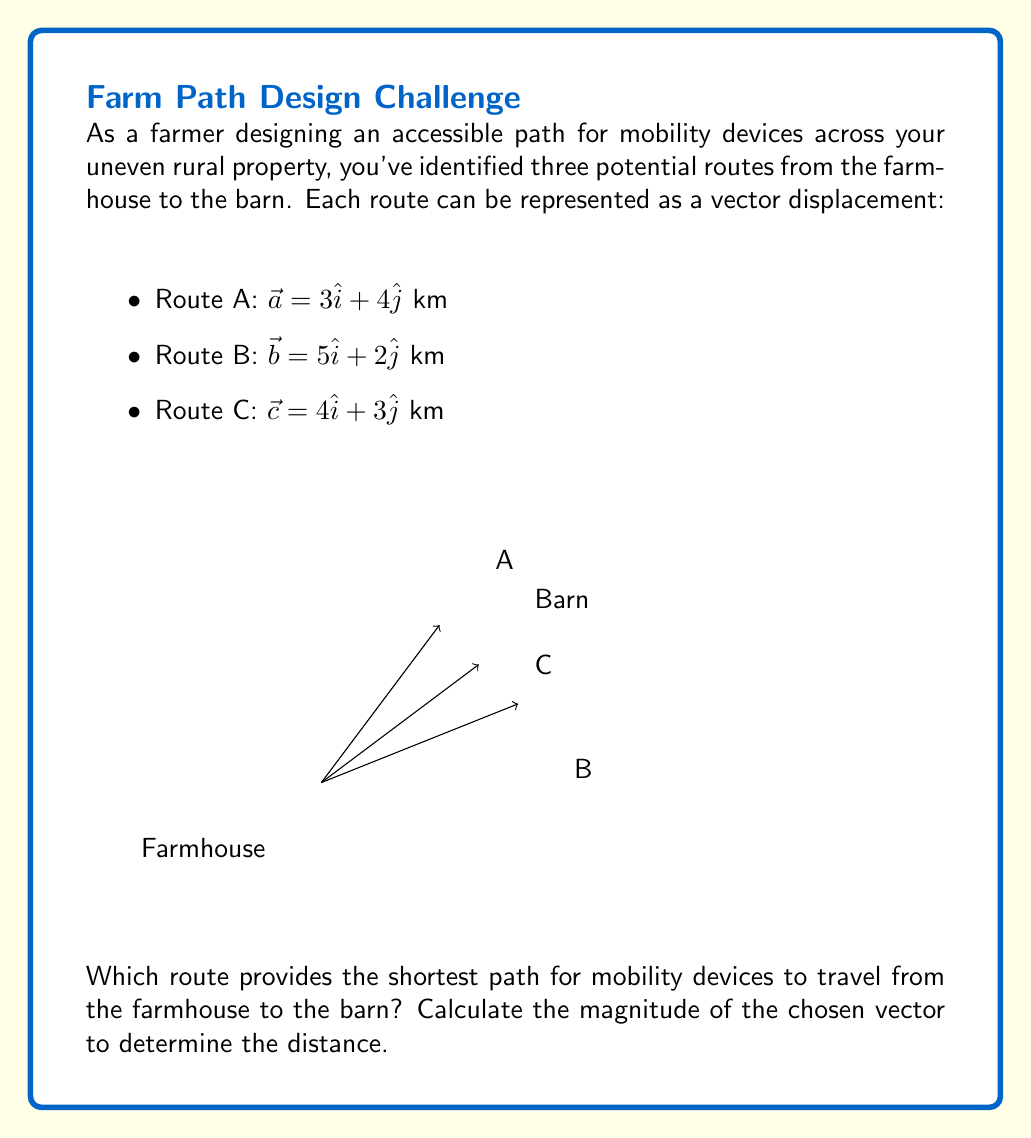Show me your answer to this math problem. To find the shortest path, we need to calculate the magnitude of each vector and compare them:

1. For Route A:
   $$|\vec{a}| = \sqrt{3^2 + 4^2} = \sqrt{9 + 16} = \sqrt{25} = 5$$ km

2. For Route B:
   $$|\vec{b}| = \sqrt{5^2 + 2^2} = \sqrt{25 + 4} = \sqrt{29} \approx 5.39$$ km

3. For Route C:
   $$|\vec{c}| = \sqrt{4^2 + 3^2} = \sqrt{16 + 9} = \sqrt{25} = 5$$ km

Comparing the magnitudes:
Route A: 5 km
Route B: 5.39 km
Route C: 5 km

Both Route A and Route C have the shortest distance of 5 km. However, since we're designing for mobility devices, we should consider the terrain represented by the vector components.

Route A: $3\hat{i} + 4\hat{j}$ has a steeper incline (larger y-component)
Route C: $4\hat{i} + 3\hat{j}$ has a gentler incline (smaller y-component)

Therefore, Route C is the most suitable choice as it provides the shortest distance with a gentler incline, making it more accessible for mobility devices.
Answer: Route C: $\vec{c} = 4\hat{i} + 3\hat{j}$, distance = 5 km 